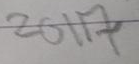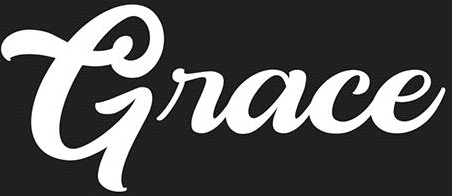Transcribe the words shown in these images in order, separated by a semicolon. 2017; Grace 